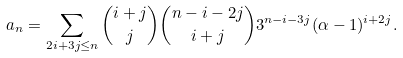<formula> <loc_0><loc_0><loc_500><loc_500>a _ { n } = \sum _ { 2 i + 3 j \leq n } \binom { i + j } { j } \binom { n - i - 2 j } { i + j } 3 ^ { n - i - 3 j } ( \alpha - 1 ) ^ { i + 2 j } .</formula> 